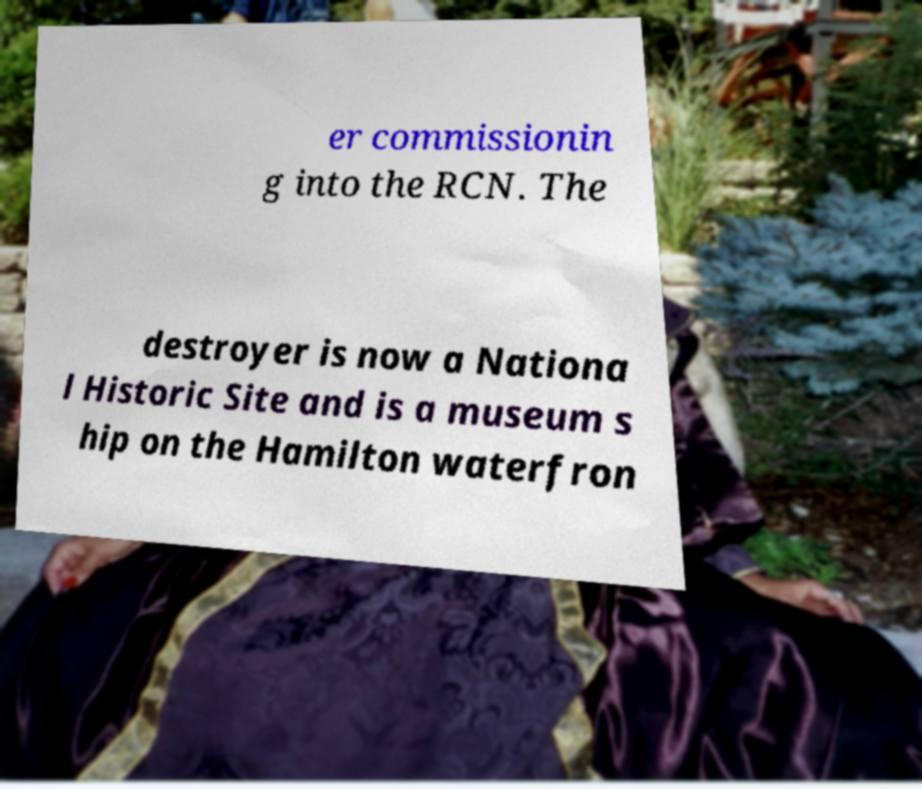Could you assist in decoding the text presented in this image and type it out clearly? er commissionin g into the RCN. The destroyer is now a Nationa l Historic Site and is a museum s hip on the Hamilton waterfron 